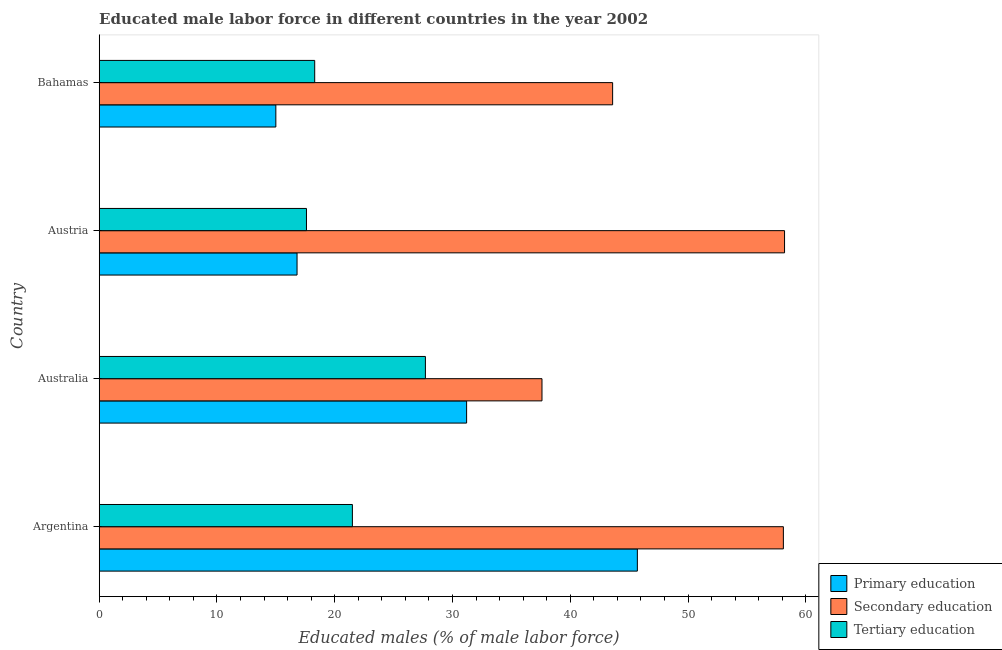How many groups of bars are there?
Your answer should be compact. 4. Are the number of bars on each tick of the Y-axis equal?
Provide a short and direct response. Yes. How many bars are there on the 1st tick from the bottom?
Ensure brevity in your answer.  3. In how many cases, is the number of bars for a given country not equal to the number of legend labels?
Make the answer very short. 0. What is the percentage of male labor force who received secondary education in Austria?
Make the answer very short. 58.2. Across all countries, what is the maximum percentage of male labor force who received tertiary education?
Ensure brevity in your answer.  27.7. Across all countries, what is the minimum percentage of male labor force who received secondary education?
Your answer should be compact. 37.6. What is the total percentage of male labor force who received primary education in the graph?
Give a very brief answer. 108.7. What is the difference between the percentage of male labor force who received tertiary education in Argentina and the percentage of male labor force who received secondary education in Australia?
Offer a very short reply. -16.1. What is the average percentage of male labor force who received primary education per country?
Provide a short and direct response. 27.18. What is the difference between the percentage of male labor force who received secondary education and percentage of male labor force who received primary education in Australia?
Keep it short and to the point. 6.4. What is the ratio of the percentage of male labor force who received tertiary education in Australia to that in Austria?
Offer a terse response. 1.57. Is the difference between the percentage of male labor force who received secondary education in Argentina and Bahamas greater than the difference between the percentage of male labor force who received tertiary education in Argentina and Bahamas?
Keep it short and to the point. Yes. What is the difference between the highest and the second highest percentage of male labor force who received primary education?
Make the answer very short. 14.5. What is the difference between the highest and the lowest percentage of male labor force who received primary education?
Offer a terse response. 30.7. In how many countries, is the percentage of male labor force who received tertiary education greater than the average percentage of male labor force who received tertiary education taken over all countries?
Ensure brevity in your answer.  2. Is the sum of the percentage of male labor force who received primary education in Argentina and Australia greater than the maximum percentage of male labor force who received tertiary education across all countries?
Offer a terse response. Yes. What does the 3rd bar from the bottom in Bahamas represents?
Offer a very short reply. Tertiary education. Is it the case that in every country, the sum of the percentage of male labor force who received primary education and percentage of male labor force who received secondary education is greater than the percentage of male labor force who received tertiary education?
Make the answer very short. Yes. How many bars are there?
Provide a short and direct response. 12. Are all the bars in the graph horizontal?
Your response must be concise. Yes. How many countries are there in the graph?
Give a very brief answer. 4. What is the difference between two consecutive major ticks on the X-axis?
Your answer should be very brief. 10. How many legend labels are there?
Provide a succinct answer. 3. What is the title of the graph?
Your answer should be very brief. Educated male labor force in different countries in the year 2002. Does "Infant(male)" appear as one of the legend labels in the graph?
Make the answer very short. No. What is the label or title of the X-axis?
Your response must be concise. Educated males (% of male labor force). What is the Educated males (% of male labor force) of Primary education in Argentina?
Provide a short and direct response. 45.7. What is the Educated males (% of male labor force) of Secondary education in Argentina?
Offer a terse response. 58.1. What is the Educated males (% of male labor force) in Tertiary education in Argentina?
Give a very brief answer. 21.5. What is the Educated males (% of male labor force) in Primary education in Australia?
Your response must be concise. 31.2. What is the Educated males (% of male labor force) in Secondary education in Australia?
Make the answer very short. 37.6. What is the Educated males (% of male labor force) of Tertiary education in Australia?
Provide a short and direct response. 27.7. What is the Educated males (% of male labor force) in Primary education in Austria?
Make the answer very short. 16.8. What is the Educated males (% of male labor force) of Secondary education in Austria?
Your answer should be very brief. 58.2. What is the Educated males (% of male labor force) in Tertiary education in Austria?
Keep it short and to the point. 17.6. What is the Educated males (% of male labor force) of Primary education in Bahamas?
Keep it short and to the point. 15. What is the Educated males (% of male labor force) of Secondary education in Bahamas?
Give a very brief answer. 43.6. What is the Educated males (% of male labor force) in Tertiary education in Bahamas?
Give a very brief answer. 18.3. Across all countries, what is the maximum Educated males (% of male labor force) in Primary education?
Your answer should be very brief. 45.7. Across all countries, what is the maximum Educated males (% of male labor force) in Secondary education?
Your answer should be very brief. 58.2. Across all countries, what is the maximum Educated males (% of male labor force) in Tertiary education?
Ensure brevity in your answer.  27.7. Across all countries, what is the minimum Educated males (% of male labor force) in Secondary education?
Give a very brief answer. 37.6. Across all countries, what is the minimum Educated males (% of male labor force) in Tertiary education?
Make the answer very short. 17.6. What is the total Educated males (% of male labor force) of Primary education in the graph?
Make the answer very short. 108.7. What is the total Educated males (% of male labor force) of Secondary education in the graph?
Offer a terse response. 197.5. What is the total Educated males (% of male labor force) in Tertiary education in the graph?
Your response must be concise. 85.1. What is the difference between the Educated males (% of male labor force) of Secondary education in Argentina and that in Australia?
Provide a succinct answer. 20.5. What is the difference between the Educated males (% of male labor force) of Primary education in Argentina and that in Austria?
Offer a terse response. 28.9. What is the difference between the Educated males (% of male labor force) of Tertiary education in Argentina and that in Austria?
Keep it short and to the point. 3.9. What is the difference between the Educated males (% of male labor force) of Primary education in Argentina and that in Bahamas?
Your answer should be compact. 30.7. What is the difference between the Educated males (% of male labor force) of Tertiary education in Argentina and that in Bahamas?
Provide a short and direct response. 3.2. What is the difference between the Educated males (% of male labor force) of Secondary education in Australia and that in Austria?
Provide a short and direct response. -20.6. What is the difference between the Educated males (% of male labor force) in Tertiary education in Australia and that in Austria?
Provide a short and direct response. 10.1. What is the difference between the Educated males (% of male labor force) of Primary education in Australia and that in Bahamas?
Give a very brief answer. 16.2. What is the difference between the Educated males (% of male labor force) in Tertiary education in Australia and that in Bahamas?
Ensure brevity in your answer.  9.4. What is the difference between the Educated males (% of male labor force) of Primary education in Argentina and the Educated males (% of male labor force) of Secondary education in Australia?
Provide a short and direct response. 8.1. What is the difference between the Educated males (% of male labor force) in Primary education in Argentina and the Educated males (% of male labor force) in Tertiary education in Australia?
Offer a terse response. 18. What is the difference between the Educated males (% of male labor force) in Secondary education in Argentina and the Educated males (% of male labor force) in Tertiary education in Australia?
Provide a short and direct response. 30.4. What is the difference between the Educated males (% of male labor force) in Primary education in Argentina and the Educated males (% of male labor force) in Secondary education in Austria?
Keep it short and to the point. -12.5. What is the difference between the Educated males (% of male labor force) of Primary education in Argentina and the Educated males (% of male labor force) of Tertiary education in Austria?
Make the answer very short. 28.1. What is the difference between the Educated males (% of male labor force) of Secondary education in Argentina and the Educated males (% of male labor force) of Tertiary education in Austria?
Your answer should be compact. 40.5. What is the difference between the Educated males (% of male labor force) in Primary education in Argentina and the Educated males (% of male labor force) in Secondary education in Bahamas?
Your answer should be compact. 2.1. What is the difference between the Educated males (% of male labor force) of Primary education in Argentina and the Educated males (% of male labor force) of Tertiary education in Bahamas?
Your answer should be very brief. 27.4. What is the difference between the Educated males (% of male labor force) of Secondary education in Argentina and the Educated males (% of male labor force) of Tertiary education in Bahamas?
Give a very brief answer. 39.8. What is the difference between the Educated males (% of male labor force) of Primary education in Australia and the Educated males (% of male labor force) of Secondary education in Austria?
Make the answer very short. -27. What is the difference between the Educated males (% of male labor force) of Secondary education in Australia and the Educated males (% of male labor force) of Tertiary education in Austria?
Offer a terse response. 20. What is the difference between the Educated males (% of male labor force) of Primary education in Australia and the Educated males (% of male labor force) of Tertiary education in Bahamas?
Ensure brevity in your answer.  12.9. What is the difference between the Educated males (% of male labor force) in Secondary education in Australia and the Educated males (% of male labor force) in Tertiary education in Bahamas?
Your answer should be compact. 19.3. What is the difference between the Educated males (% of male labor force) of Primary education in Austria and the Educated males (% of male labor force) of Secondary education in Bahamas?
Make the answer very short. -26.8. What is the difference between the Educated males (% of male labor force) of Primary education in Austria and the Educated males (% of male labor force) of Tertiary education in Bahamas?
Provide a succinct answer. -1.5. What is the difference between the Educated males (% of male labor force) of Secondary education in Austria and the Educated males (% of male labor force) of Tertiary education in Bahamas?
Make the answer very short. 39.9. What is the average Educated males (% of male labor force) of Primary education per country?
Offer a very short reply. 27.18. What is the average Educated males (% of male labor force) of Secondary education per country?
Your answer should be compact. 49.38. What is the average Educated males (% of male labor force) in Tertiary education per country?
Provide a succinct answer. 21.27. What is the difference between the Educated males (% of male labor force) in Primary education and Educated males (% of male labor force) in Secondary education in Argentina?
Ensure brevity in your answer.  -12.4. What is the difference between the Educated males (% of male labor force) of Primary education and Educated males (% of male labor force) of Tertiary education in Argentina?
Your answer should be compact. 24.2. What is the difference between the Educated males (% of male labor force) of Secondary education and Educated males (% of male labor force) of Tertiary education in Argentina?
Keep it short and to the point. 36.6. What is the difference between the Educated males (% of male labor force) in Primary education and Educated males (% of male labor force) in Secondary education in Australia?
Make the answer very short. -6.4. What is the difference between the Educated males (% of male labor force) in Secondary education and Educated males (% of male labor force) in Tertiary education in Australia?
Ensure brevity in your answer.  9.9. What is the difference between the Educated males (% of male labor force) of Primary education and Educated males (% of male labor force) of Secondary education in Austria?
Your response must be concise. -41.4. What is the difference between the Educated males (% of male labor force) in Primary education and Educated males (% of male labor force) in Tertiary education in Austria?
Make the answer very short. -0.8. What is the difference between the Educated males (% of male labor force) in Secondary education and Educated males (% of male labor force) in Tertiary education in Austria?
Give a very brief answer. 40.6. What is the difference between the Educated males (% of male labor force) of Primary education and Educated males (% of male labor force) of Secondary education in Bahamas?
Your answer should be compact. -28.6. What is the difference between the Educated males (% of male labor force) of Secondary education and Educated males (% of male labor force) of Tertiary education in Bahamas?
Make the answer very short. 25.3. What is the ratio of the Educated males (% of male labor force) of Primary education in Argentina to that in Australia?
Provide a succinct answer. 1.46. What is the ratio of the Educated males (% of male labor force) of Secondary education in Argentina to that in Australia?
Provide a short and direct response. 1.55. What is the ratio of the Educated males (% of male labor force) in Tertiary education in Argentina to that in Australia?
Give a very brief answer. 0.78. What is the ratio of the Educated males (% of male labor force) in Primary education in Argentina to that in Austria?
Make the answer very short. 2.72. What is the ratio of the Educated males (% of male labor force) in Secondary education in Argentina to that in Austria?
Your answer should be very brief. 1. What is the ratio of the Educated males (% of male labor force) of Tertiary education in Argentina to that in Austria?
Your response must be concise. 1.22. What is the ratio of the Educated males (% of male labor force) of Primary education in Argentina to that in Bahamas?
Your answer should be compact. 3.05. What is the ratio of the Educated males (% of male labor force) of Secondary education in Argentina to that in Bahamas?
Offer a very short reply. 1.33. What is the ratio of the Educated males (% of male labor force) in Tertiary education in Argentina to that in Bahamas?
Your answer should be compact. 1.17. What is the ratio of the Educated males (% of male labor force) in Primary education in Australia to that in Austria?
Offer a very short reply. 1.86. What is the ratio of the Educated males (% of male labor force) of Secondary education in Australia to that in Austria?
Ensure brevity in your answer.  0.65. What is the ratio of the Educated males (% of male labor force) of Tertiary education in Australia to that in Austria?
Your response must be concise. 1.57. What is the ratio of the Educated males (% of male labor force) in Primary education in Australia to that in Bahamas?
Your answer should be compact. 2.08. What is the ratio of the Educated males (% of male labor force) of Secondary education in Australia to that in Bahamas?
Keep it short and to the point. 0.86. What is the ratio of the Educated males (% of male labor force) of Tertiary education in Australia to that in Bahamas?
Your answer should be very brief. 1.51. What is the ratio of the Educated males (% of male labor force) of Primary education in Austria to that in Bahamas?
Make the answer very short. 1.12. What is the ratio of the Educated males (% of male labor force) in Secondary education in Austria to that in Bahamas?
Your answer should be very brief. 1.33. What is the ratio of the Educated males (% of male labor force) in Tertiary education in Austria to that in Bahamas?
Your answer should be very brief. 0.96. What is the difference between the highest and the second highest Educated males (% of male labor force) in Primary education?
Keep it short and to the point. 14.5. What is the difference between the highest and the second highest Educated males (% of male labor force) of Secondary education?
Provide a short and direct response. 0.1. What is the difference between the highest and the lowest Educated males (% of male labor force) of Primary education?
Your response must be concise. 30.7. What is the difference between the highest and the lowest Educated males (% of male labor force) of Secondary education?
Offer a terse response. 20.6. What is the difference between the highest and the lowest Educated males (% of male labor force) in Tertiary education?
Keep it short and to the point. 10.1. 